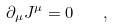Convert formula to latex. <formula><loc_0><loc_0><loc_500><loc_500>\partial _ { \mu } J ^ { \mu } = 0 \quad ,</formula> 